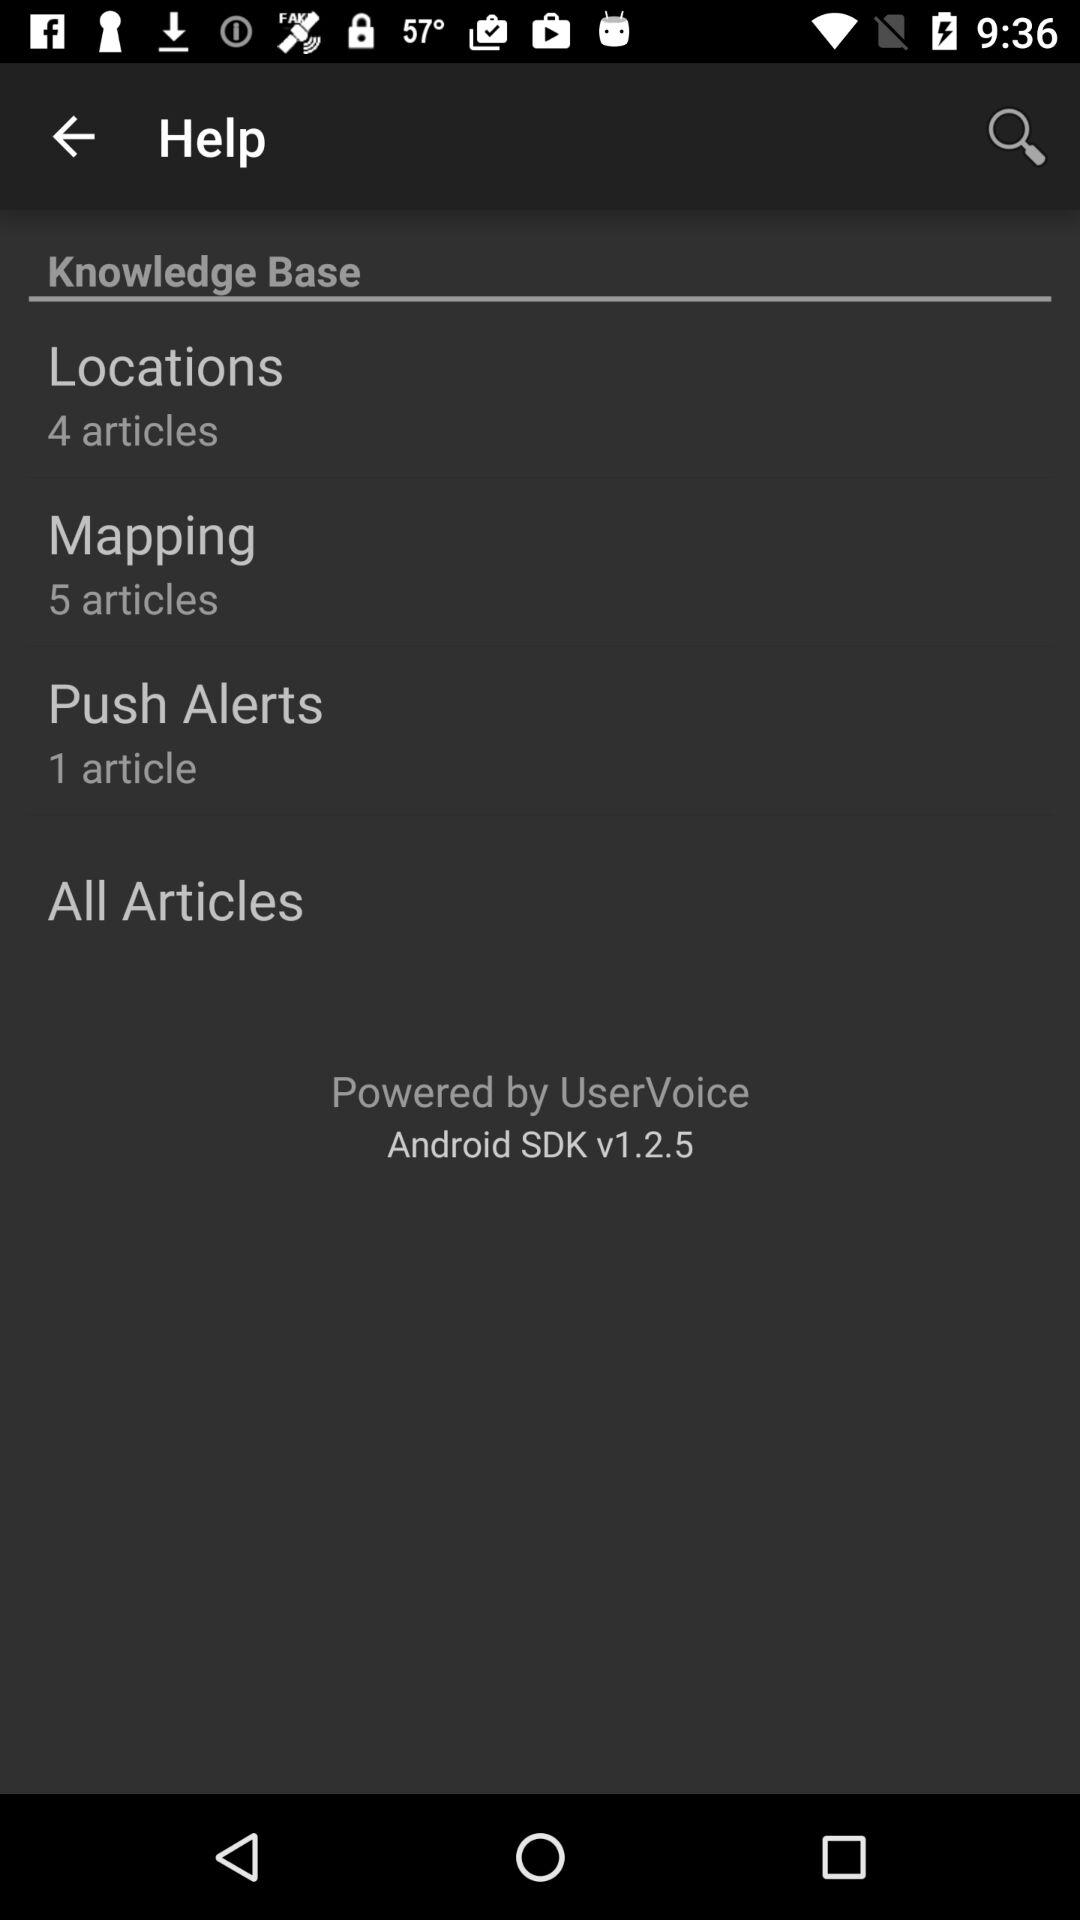What is the total number of articles in the "Mapping"? The total number of articles in the "Mapping" is 5. 